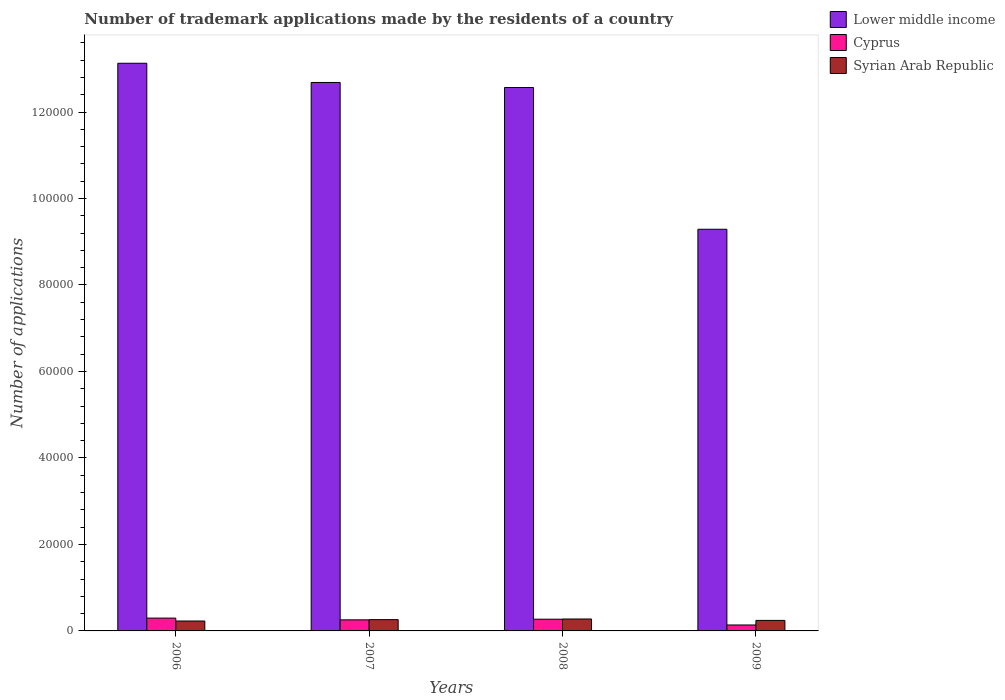How many groups of bars are there?
Your response must be concise. 4. How many bars are there on the 4th tick from the right?
Make the answer very short. 3. What is the label of the 4th group of bars from the left?
Your answer should be compact. 2009. What is the number of trademark applications made by the residents in Lower middle income in 2007?
Offer a very short reply. 1.27e+05. Across all years, what is the maximum number of trademark applications made by the residents in Lower middle income?
Your answer should be very brief. 1.31e+05. Across all years, what is the minimum number of trademark applications made by the residents in Lower middle income?
Ensure brevity in your answer.  9.29e+04. In which year was the number of trademark applications made by the residents in Syrian Arab Republic maximum?
Give a very brief answer. 2008. In which year was the number of trademark applications made by the residents in Cyprus minimum?
Provide a succinct answer. 2009. What is the total number of trademark applications made by the residents in Lower middle income in the graph?
Make the answer very short. 4.77e+05. What is the difference between the number of trademark applications made by the residents in Cyprus in 2006 and that in 2009?
Offer a terse response. 1589. What is the difference between the number of trademark applications made by the residents in Cyprus in 2007 and the number of trademark applications made by the residents in Lower middle income in 2006?
Provide a short and direct response. -1.29e+05. What is the average number of trademark applications made by the residents in Cyprus per year?
Offer a very short reply. 2403. In the year 2007, what is the difference between the number of trademark applications made by the residents in Cyprus and number of trademark applications made by the residents in Syrian Arab Republic?
Offer a very short reply. -50. What is the ratio of the number of trademark applications made by the residents in Syrian Arab Republic in 2006 to that in 2008?
Give a very brief answer. 0.83. Is the difference between the number of trademark applications made by the residents in Cyprus in 2008 and 2009 greater than the difference between the number of trademark applications made by the residents in Syrian Arab Republic in 2008 and 2009?
Give a very brief answer. Yes. What is the difference between the highest and the second highest number of trademark applications made by the residents in Cyprus?
Give a very brief answer. 251. What is the difference between the highest and the lowest number of trademark applications made by the residents in Syrian Arab Republic?
Your answer should be very brief. 465. In how many years, is the number of trademark applications made by the residents in Syrian Arab Republic greater than the average number of trademark applications made by the residents in Syrian Arab Republic taken over all years?
Your answer should be compact. 2. Is the sum of the number of trademark applications made by the residents in Lower middle income in 2006 and 2007 greater than the maximum number of trademark applications made by the residents in Syrian Arab Republic across all years?
Ensure brevity in your answer.  Yes. What does the 2nd bar from the left in 2008 represents?
Give a very brief answer. Cyprus. What does the 1st bar from the right in 2009 represents?
Your answer should be very brief. Syrian Arab Republic. Is it the case that in every year, the sum of the number of trademark applications made by the residents in Cyprus and number of trademark applications made by the residents in Syrian Arab Republic is greater than the number of trademark applications made by the residents in Lower middle income?
Your answer should be compact. No. How many bars are there?
Offer a very short reply. 12. Are all the bars in the graph horizontal?
Your response must be concise. No. Are the values on the major ticks of Y-axis written in scientific E-notation?
Provide a succinct answer. No. Does the graph contain any zero values?
Provide a short and direct response. No. Does the graph contain grids?
Offer a very short reply. No. Where does the legend appear in the graph?
Provide a succinct answer. Top right. How many legend labels are there?
Keep it short and to the point. 3. How are the legend labels stacked?
Offer a very short reply. Vertical. What is the title of the graph?
Make the answer very short. Number of trademark applications made by the residents of a country. Does "Eritrea" appear as one of the legend labels in the graph?
Offer a very short reply. No. What is the label or title of the X-axis?
Your response must be concise. Years. What is the label or title of the Y-axis?
Give a very brief answer. Number of applications. What is the Number of applications in Lower middle income in 2006?
Offer a very short reply. 1.31e+05. What is the Number of applications in Cyprus in 2006?
Offer a very short reply. 2964. What is the Number of applications of Syrian Arab Republic in 2006?
Your response must be concise. 2292. What is the Number of applications of Lower middle income in 2007?
Make the answer very short. 1.27e+05. What is the Number of applications of Cyprus in 2007?
Make the answer very short. 2560. What is the Number of applications in Syrian Arab Republic in 2007?
Provide a short and direct response. 2610. What is the Number of applications in Lower middle income in 2008?
Give a very brief answer. 1.26e+05. What is the Number of applications of Cyprus in 2008?
Provide a succinct answer. 2713. What is the Number of applications in Syrian Arab Republic in 2008?
Make the answer very short. 2757. What is the Number of applications of Lower middle income in 2009?
Keep it short and to the point. 9.29e+04. What is the Number of applications of Cyprus in 2009?
Your answer should be compact. 1375. What is the Number of applications of Syrian Arab Republic in 2009?
Your answer should be compact. 2432. Across all years, what is the maximum Number of applications of Lower middle income?
Make the answer very short. 1.31e+05. Across all years, what is the maximum Number of applications in Cyprus?
Offer a terse response. 2964. Across all years, what is the maximum Number of applications of Syrian Arab Republic?
Make the answer very short. 2757. Across all years, what is the minimum Number of applications in Lower middle income?
Keep it short and to the point. 9.29e+04. Across all years, what is the minimum Number of applications of Cyprus?
Make the answer very short. 1375. Across all years, what is the minimum Number of applications in Syrian Arab Republic?
Keep it short and to the point. 2292. What is the total Number of applications in Lower middle income in the graph?
Make the answer very short. 4.77e+05. What is the total Number of applications of Cyprus in the graph?
Offer a very short reply. 9612. What is the total Number of applications in Syrian Arab Republic in the graph?
Keep it short and to the point. 1.01e+04. What is the difference between the Number of applications of Lower middle income in 2006 and that in 2007?
Your answer should be very brief. 4444. What is the difference between the Number of applications in Cyprus in 2006 and that in 2007?
Keep it short and to the point. 404. What is the difference between the Number of applications of Syrian Arab Republic in 2006 and that in 2007?
Provide a succinct answer. -318. What is the difference between the Number of applications in Lower middle income in 2006 and that in 2008?
Your answer should be compact. 5611. What is the difference between the Number of applications of Cyprus in 2006 and that in 2008?
Give a very brief answer. 251. What is the difference between the Number of applications in Syrian Arab Republic in 2006 and that in 2008?
Your answer should be very brief. -465. What is the difference between the Number of applications of Lower middle income in 2006 and that in 2009?
Your answer should be compact. 3.84e+04. What is the difference between the Number of applications in Cyprus in 2006 and that in 2009?
Offer a terse response. 1589. What is the difference between the Number of applications of Syrian Arab Republic in 2006 and that in 2009?
Make the answer very short. -140. What is the difference between the Number of applications of Lower middle income in 2007 and that in 2008?
Your response must be concise. 1167. What is the difference between the Number of applications of Cyprus in 2007 and that in 2008?
Give a very brief answer. -153. What is the difference between the Number of applications of Syrian Arab Republic in 2007 and that in 2008?
Provide a short and direct response. -147. What is the difference between the Number of applications of Lower middle income in 2007 and that in 2009?
Your answer should be very brief. 3.39e+04. What is the difference between the Number of applications in Cyprus in 2007 and that in 2009?
Ensure brevity in your answer.  1185. What is the difference between the Number of applications of Syrian Arab Republic in 2007 and that in 2009?
Give a very brief answer. 178. What is the difference between the Number of applications in Lower middle income in 2008 and that in 2009?
Provide a succinct answer. 3.28e+04. What is the difference between the Number of applications of Cyprus in 2008 and that in 2009?
Offer a terse response. 1338. What is the difference between the Number of applications of Syrian Arab Republic in 2008 and that in 2009?
Provide a short and direct response. 325. What is the difference between the Number of applications in Lower middle income in 2006 and the Number of applications in Cyprus in 2007?
Offer a very short reply. 1.29e+05. What is the difference between the Number of applications in Lower middle income in 2006 and the Number of applications in Syrian Arab Republic in 2007?
Your answer should be very brief. 1.29e+05. What is the difference between the Number of applications in Cyprus in 2006 and the Number of applications in Syrian Arab Republic in 2007?
Ensure brevity in your answer.  354. What is the difference between the Number of applications of Lower middle income in 2006 and the Number of applications of Cyprus in 2008?
Your answer should be compact. 1.29e+05. What is the difference between the Number of applications in Lower middle income in 2006 and the Number of applications in Syrian Arab Republic in 2008?
Ensure brevity in your answer.  1.29e+05. What is the difference between the Number of applications in Cyprus in 2006 and the Number of applications in Syrian Arab Republic in 2008?
Your answer should be compact. 207. What is the difference between the Number of applications in Lower middle income in 2006 and the Number of applications in Cyprus in 2009?
Give a very brief answer. 1.30e+05. What is the difference between the Number of applications in Lower middle income in 2006 and the Number of applications in Syrian Arab Republic in 2009?
Offer a very short reply. 1.29e+05. What is the difference between the Number of applications of Cyprus in 2006 and the Number of applications of Syrian Arab Republic in 2009?
Keep it short and to the point. 532. What is the difference between the Number of applications in Lower middle income in 2007 and the Number of applications in Cyprus in 2008?
Your answer should be compact. 1.24e+05. What is the difference between the Number of applications in Lower middle income in 2007 and the Number of applications in Syrian Arab Republic in 2008?
Ensure brevity in your answer.  1.24e+05. What is the difference between the Number of applications in Cyprus in 2007 and the Number of applications in Syrian Arab Republic in 2008?
Your response must be concise. -197. What is the difference between the Number of applications of Lower middle income in 2007 and the Number of applications of Cyprus in 2009?
Your answer should be compact. 1.25e+05. What is the difference between the Number of applications in Lower middle income in 2007 and the Number of applications in Syrian Arab Republic in 2009?
Make the answer very short. 1.24e+05. What is the difference between the Number of applications in Cyprus in 2007 and the Number of applications in Syrian Arab Republic in 2009?
Make the answer very short. 128. What is the difference between the Number of applications of Lower middle income in 2008 and the Number of applications of Cyprus in 2009?
Your answer should be compact. 1.24e+05. What is the difference between the Number of applications in Lower middle income in 2008 and the Number of applications in Syrian Arab Republic in 2009?
Make the answer very short. 1.23e+05. What is the difference between the Number of applications of Cyprus in 2008 and the Number of applications of Syrian Arab Republic in 2009?
Your answer should be compact. 281. What is the average Number of applications in Lower middle income per year?
Give a very brief answer. 1.19e+05. What is the average Number of applications of Cyprus per year?
Ensure brevity in your answer.  2403. What is the average Number of applications in Syrian Arab Republic per year?
Offer a very short reply. 2522.75. In the year 2006, what is the difference between the Number of applications in Lower middle income and Number of applications in Cyprus?
Ensure brevity in your answer.  1.28e+05. In the year 2006, what is the difference between the Number of applications of Lower middle income and Number of applications of Syrian Arab Republic?
Provide a short and direct response. 1.29e+05. In the year 2006, what is the difference between the Number of applications of Cyprus and Number of applications of Syrian Arab Republic?
Keep it short and to the point. 672. In the year 2007, what is the difference between the Number of applications in Lower middle income and Number of applications in Cyprus?
Your answer should be very brief. 1.24e+05. In the year 2007, what is the difference between the Number of applications in Lower middle income and Number of applications in Syrian Arab Republic?
Provide a short and direct response. 1.24e+05. In the year 2007, what is the difference between the Number of applications of Cyprus and Number of applications of Syrian Arab Republic?
Offer a very short reply. -50. In the year 2008, what is the difference between the Number of applications of Lower middle income and Number of applications of Cyprus?
Provide a succinct answer. 1.23e+05. In the year 2008, what is the difference between the Number of applications of Lower middle income and Number of applications of Syrian Arab Republic?
Keep it short and to the point. 1.23e+05. In the year 2008, what is the difference between the Number of applications in Cyprus and Number of applications in Syrian Arab Republic?
Your response must be concise. -44. In the year 2009, what is the difference between the Number of applications of Lower middle income and Number of applications of Cyprus?
Provide a short and direct response. 9.15e+04. In the year 2009, what is the difference between the Number of applications in Lower middle income and Number of applications in Syrian Arab Republic?
Make the answer very short. 9.05e+04. In the year 2009, what is the difference between the Number of applications in Cyprus and Number of applications in Syrian Arab Republic?
Give a very brief answer. -1057. What is the ratio of the Number of applications of Lower middle income in 2006 to that in 2007?
Give a very brief answer. 1.03. What is the ratio of the Number of applications in Cyprus in 2006 to that in 2007?
Keep it short and to the point. 1.16. What is the ratio of the Number of applications in Syrian Arab Republic in 2006 to that in 2007?
Your response must be concise. 0.88. What is the ratio of the Number of applications of Lower middle income in 2006 to that in 2008?
Your response must be concise. 1.04. What is the ratio of the Number of applications in Cyprus in 2006 to that in 2008?
Provide a succinct answer. 1.09. What is the ratio of the Number of applications in Syrian Arab Republic in 2006 to that in 2008?
Your answer should be compact. 0.83. What is the ratio of the Number of applications of Lower middle income in 2006 to that in 2009?
Ensure brevity in your answer.  1.41. What is the ratio of the Number of applications in Cyprus in 2006 to that in 2009?
Provide a short and direct response. 2.16. What is the ratio of the Number of applications in Syrian Arab Republic in 2006 to that in 2009?
Provide a short and direct response. 0.94. What is the ratio of the Number of applications of Lower middle income in 2007 to that in 2008?
Your answer should be very brief. 1.01. What is the ratio of the Number of applications in Cyprus in 2007 to that in 2008?
Your response must be concise. 0.94. What is the ratio of the Number of applications of Syrian Arab Republic in 2007 to that in 2008?
Your answer should be very brief. 0.95. What is the ratio of the Number of applications of Lower middle income in 2007 to that in 2009?
Your answer should be very brief. 1.37. What is the ratio of the Number of applications of Cyprus in 2007 to that in 2009?
Your answer should be compact. 1.86. What is the ratio of the Number of applications of Syrian Arab Republic in 2007 to that in 2009?
Your answer should be compact. 1.07. What is the ratio of the Number of applications in Lower middle income in 2008 to that in 2009?
Ensure brevity in your answer.  1.35. What is the ratio of the Number of applications in Cyprus in 2008 to that in 2009?
Your answer should be very brief. 1.97. What is the ratio of the Number of applications in Syrian Arab Republic in 2008 to that in 2009?
Your response must be concise. 1.13. What is the difference between the highest and the second highest Number of applications of Lower middle income?
Offer a very short reply. 4444. What is the difference between the highest and the second highest Number of applications of Cyprus?
Make the answer very short. 251. What is the difference between the highest and the second highest Number of applications of Syrian Arab Republic?
Your answer should be very brief. 147. What is the difference between the highest and the lowest Number of applications in Lower middle income?
Ensure brevity in your answer.  3.84e+04. What is the difference between the highest and the lowest Number of applications of Cyprus?
Provide a short and direct response. 1589. What is the difference between the highest and the lowest Number of applications of Syrian Arab Republic?
Your answer should be compact. 465. 